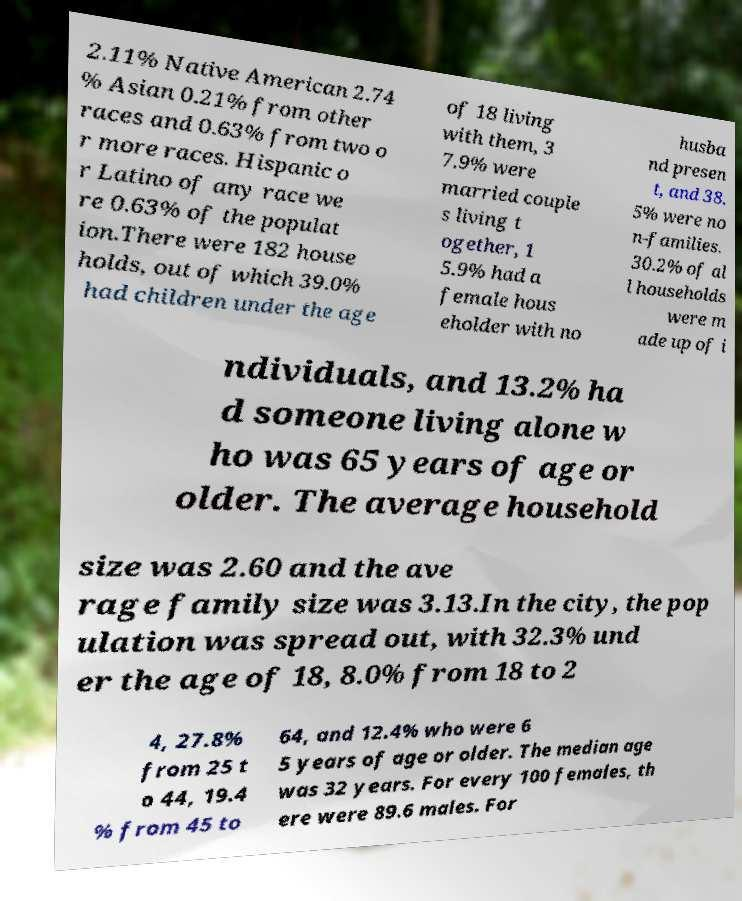I need the written content from this picture converted into text. Can you do that? 2.11% Native American 2.74 % Asian 0.21% from other races and 0.63% from two o r more races. Hispanic o r Latino of any race we re 0.63% of the populat ion.There were 182 house holds, out of which 39.0% had children under the age of 18 living with them, 3 7.9% were married couple s living t ogether, 1 5.9% had a female hous eholder with no husba nd presen t, and 38. 5% were no n-families. 30.2% of al l households were m ade up of i ndividuals, and 13.2% ha d someone living alone w ho was 65 years of age or older. The average household size was 2.60 and the ave rage family size was 3.13.In the city, the pop ulation was spread out, with 32.3% und er the age of 18, 8.0% from 18 to 2 4, 27.8% from 25 t o 44, 19.4 % from 45 to 64, and 12.4% who were 6 5 years of age or older. The median age was 32 years. For every 100 females, th ere were 89.6 males. For 